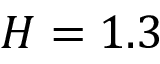Convert formula to latex. <formula><loc_0><loc_0><loc_500><loc_500>H = 1 . 3</formula> 